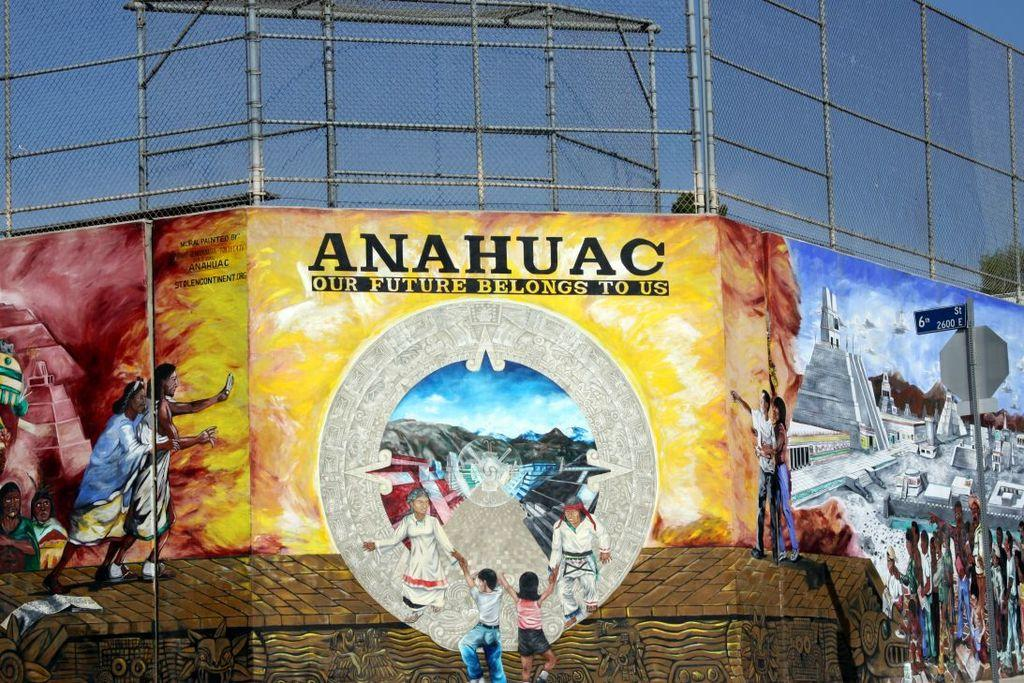Provide a one-sentence caption for the provided image. A large yellow poster with a drawing of people on a emblem with the words Anahuac our future belongs to us on the poster. 